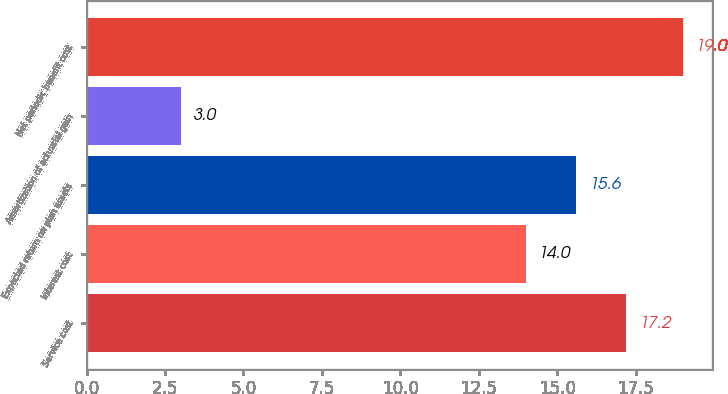<chart> <loc_0><loc_0><loc_500><loc_500><bar_chart><fcel>Service cost<fcel>Interest cost<fcel>Expected return on plan assets<fcel>Amortization of actuarial gain<fcel>Net periodic benefit cost<nl><fcel>17.2<fcel>14<fcel>15.6<fcel>3<fcel>19<nl></chart> 